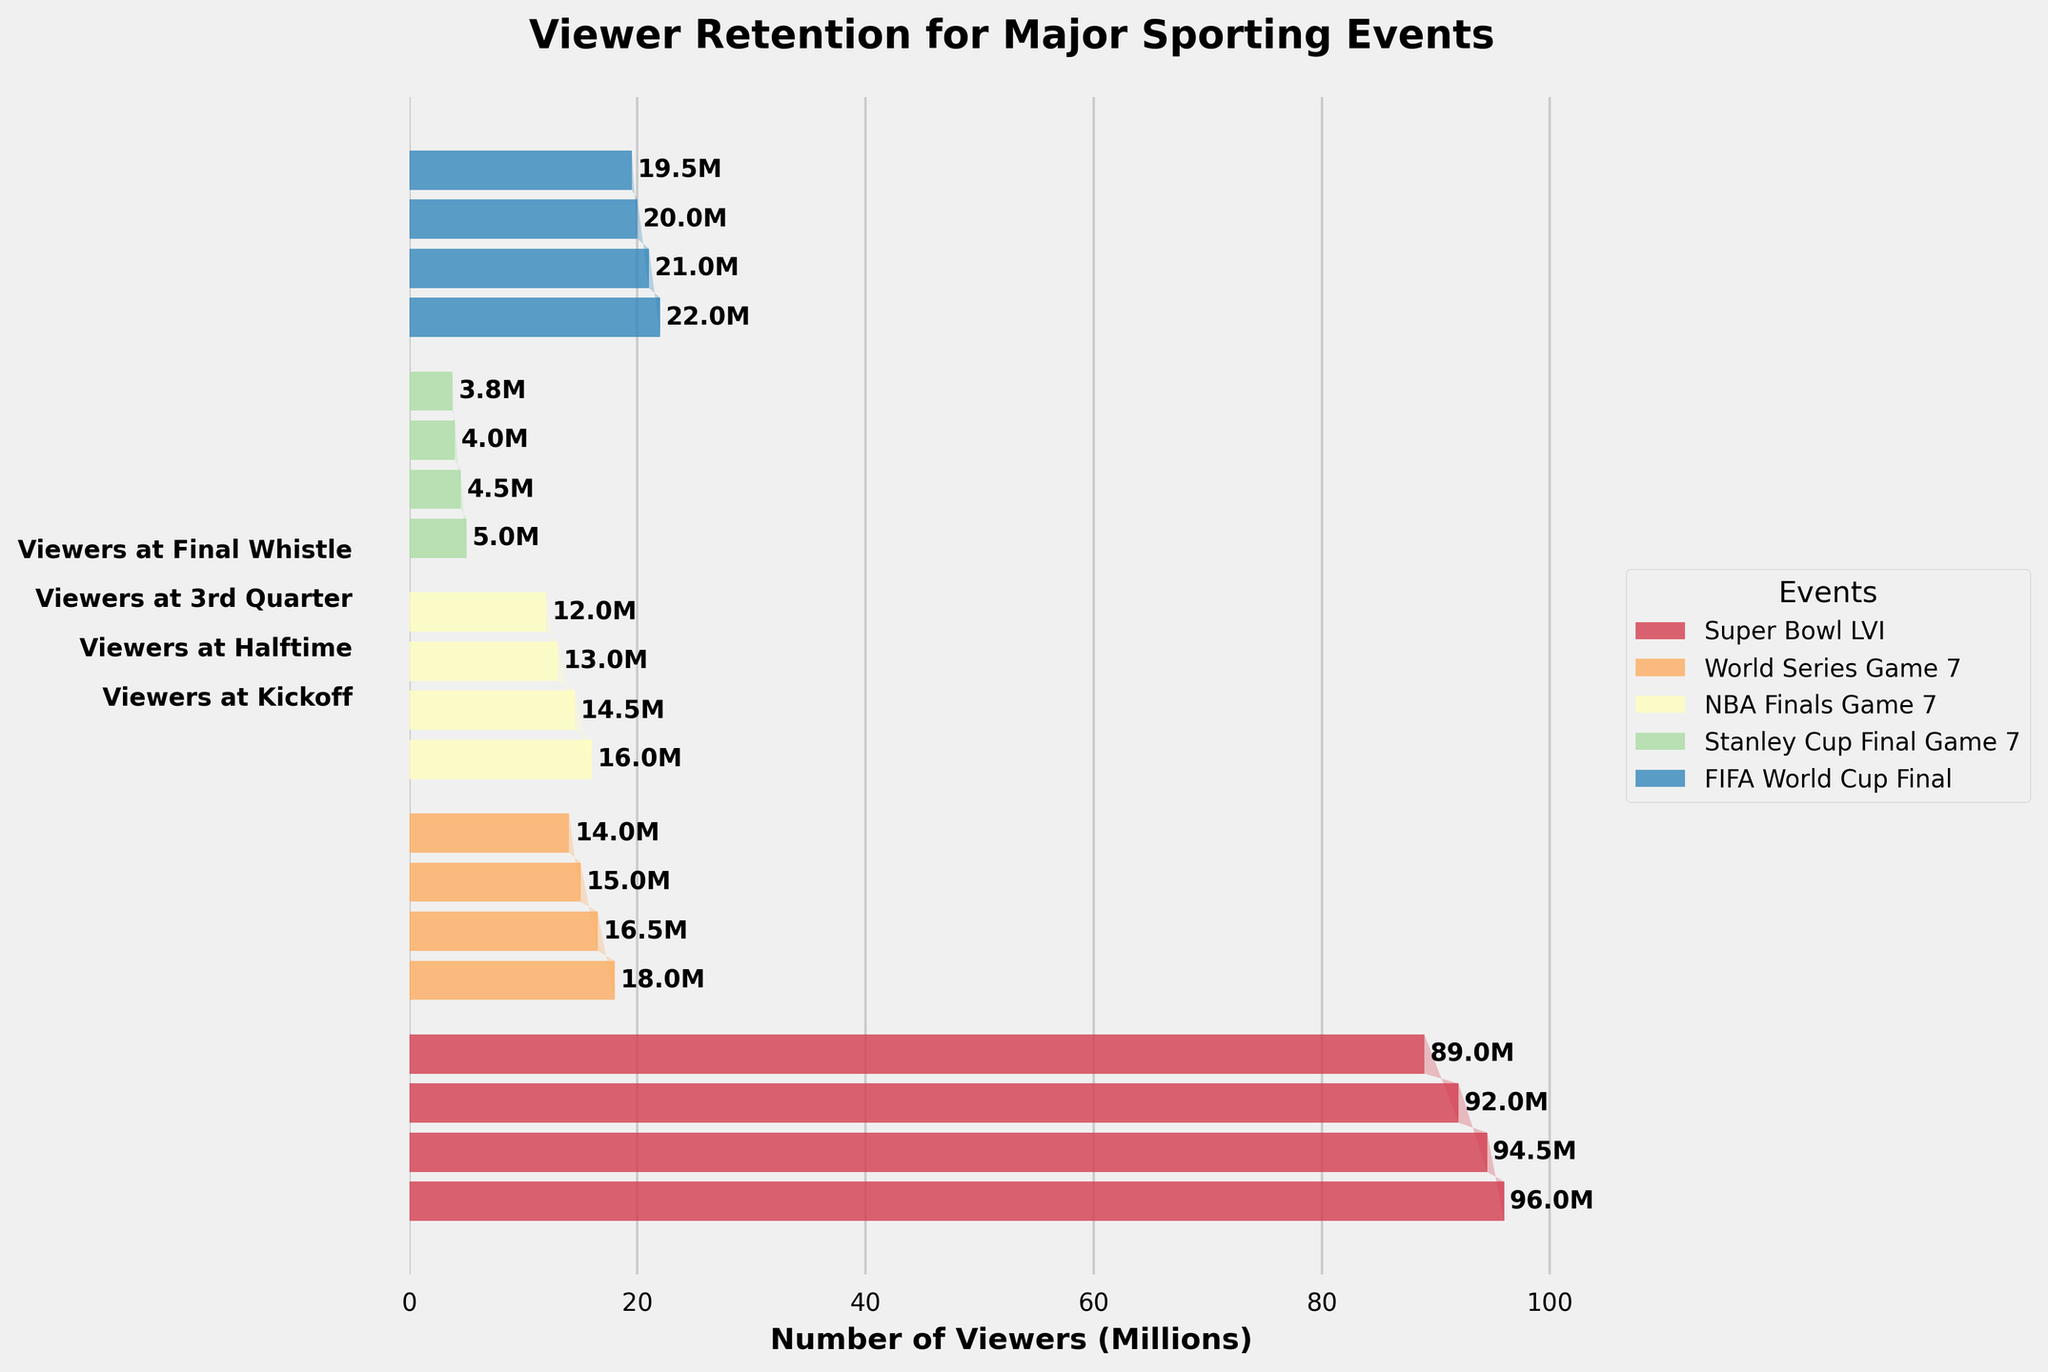What is the title of the figure? The title is usually found at the top of the figure. In this case, it reads "Viewer Retention for Major Sporting Events".
Answer: Viewer Retention for Major Sporting Events Which event had the highest number of viewers at kickoff? By looking at the bars for each event at the kickoff stage, the Super Bowl LVI has the longest bar, indicating the highest number of viewers.
Answer: Super Bowl LVI How many stages are represented in this funnel chart for viewer retention? The stages can be identified by the horizontal bars and labels on the y-axis. There are four stages: "Viewers at Kickoff", "Viewers at Halftime", "Viewers at 3rd Quarter", and "Viewers at Final Whistle".
Answer: Four Which event had the lowest number of viewers at the final whistle? Viewing the chart at the final whistle stage, the event with the shortest bar is the Stanley Cup Final Game 7.
Answer: Stanley Cup Final Game 7 Which event experienced the largest drop in viewers from kickoff to final whistle in millions? By calculating the difference between the kickoff and final whistle values for each event: 
Super Bowl LVI: 96 - 89 = 7M 
World Series Game 7: 18 - 14 = 4M 
NBA Finals Game 7: 16 - 12 = 4M 
Stanley Cup Final Game 7: 5 - 3.8 = 1.2M 
FIFA World Cup Final: 22 - 19.5 = 2.5M. 
Super Bowl LVI has the largest drop.
Answer: Super Bowl LVI Which event had the smallest relative decrease in viewers from kickoff to final whistle? Relative decrease is calculated as (kickoff - final whistle)/kickoff for each event:
Super Bowl LVI: (96 - 89) / 96 = 0.0729
World Series Game 7: (18 - 14) / 18 = 0.2222
NBA Finals Game 7: (16 - 12) / 16 = 0.25
Stanley Cup Final Game 7: (5 - 3.8) / 5 = 0.24
FIFA World Cup Final: (22 - 19.5) / 22 = 0.1136
Super Bowl LVI had the smallest relative decrease.
Answer: Super Bowl LVI Compare viewer retention from kickoff to halftime: Which event had the smallest loss of viewers? By calculating the difference between kickoff and halftime viewers for each event:
Super Bowl LVI: 96 - 94.5 = 1.5M 
World Series Game 7: 18 - 16.5 = 1.5M 
NBA Finals Game 7: 16 - 14.5 = 1.5M 
Stanley Cup Final Game 7: 5 - 4.5 = 0.5M 
FIFA World Cup Final: 22 - 21 = 1M.
Stanley Cup Final Game 7 had the smallest loss.
Answer: Stanley Cup Final Game 7 What is the average number of viewers at halftime across all events? To find the average, sum all the viewers at halftime for each event and divide by the number of events: (94.5 + 16.5 + 14.5 + 4.5 + 21)M / 5 = 30.2M
Answer: 30.2M Between the NBA Finals Game 7 and World Series Game 7, which retained a higher percentage of viewers at the final whistle? Calculate the percentage retained for each:
NBA Finals Game 7: (12 / 16) * 100 ≈ 75%
World Series Game 7: (14 / 18) * 100 ≈ 77.78%
World Series Game 7 retained a higher percentage.
Answer: World Series Game 7 